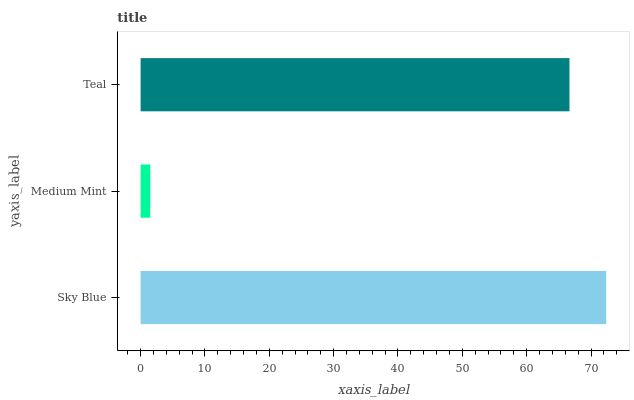Is Medium Mint the minimum?
Answer yes or no. Yes. Is Sky Blue the maximum?
Answer yes or no. Yes. Is Teal the minimum?
Answer yes or no. No. Is Teal the maximum?
Answer yes or no. No. Is Teal greater than Medium Mint?
Answer yes or no. Yes. Is Medium Mint less than Teal?
Answer yes or no. Yes. Is Medium Mint greater than Teal?
Answer yes or no. No. Is Teal less than Medium Mint?
Answer yes or no. No. Is Teal the high median?
Answer yes or no. Yes. Is Teal the low median?
Answer yes or no. Yes. Is Sky Blue the high median?
Answer yes or no. No. Is Medium Mint the low median?
Answer yes or no. No. 